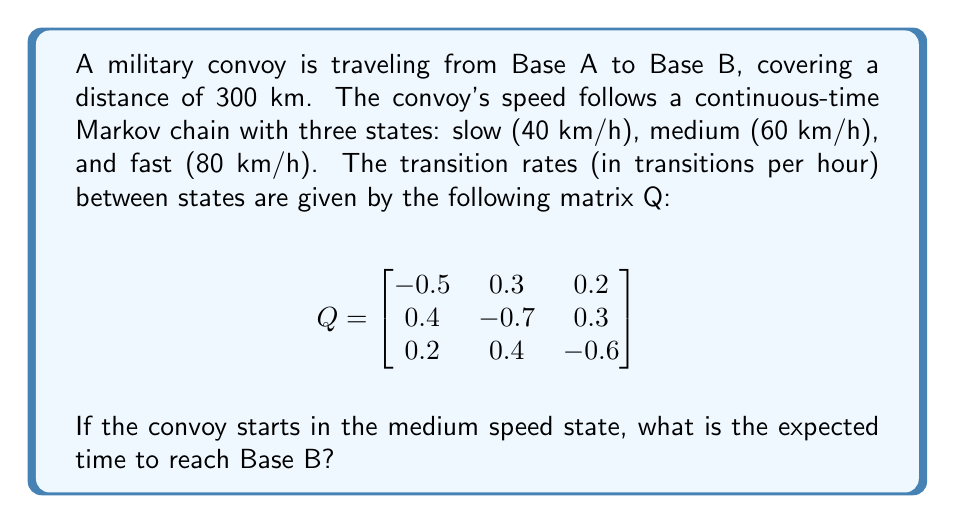Can you answer this question? To solve this problem, we need to use the theory of continuous-time Markov chains and expected hitting times. Let's approach this step-by-step:

1) First, we need to find the stationary distribution π of the Markov chain. This satisfies πQ = 0 and Σπᵢ = 1. Solving this system of equations:

   $$\begin{align}
   -0.5π₁ + 0.4π₂ + 0.2π₃ &= 0 \\
   0.3π₁ - 0.7π₂ + 0.4π₃ &= 0 \\
   π₁ + π₂ + π₃ &= 1
   \end{align}$$

   We get: π ≈ (0.3846, 0.3077, 0.3077)

2) Now, we can calculate the expected speed of the convoy:

   $$E[V] = 40 * 0.3846 + 60 * 0.3077 + 80 * 0.3077 ≈ 58.46 \text{ km/h}$$

3) The expected time to cover 300 km at this average speed would be:

   $$E[T] = \frac{300}{58.46} ≈ 5.13 \text{ hours}$$

However, this is not the correct answer because the convoy starts in the medium speed state, not in the stationary distribution.

4) To account for the initial state, we need to use the fundamental matrix approach. Let T be the expected time to reach Base B. Then:

   $$T = e + QT$$

   where e is a column vector of ones and Q is our rate matrix.

5) Solving this equation:

   $$(I - Q)T = e$$
   $$T = (I - Q)^{-1}e$$

6) Calculating $(I - Q)^{-1}$:

   $$(I - Q)^{-1} ≈ \begin{bmatrix}
   2.6667 & 1.3333 & 1.1111 \\
   1.7778 & 2.4444 & 1.3333 \\
   1.3333 & 1.5556 & 2.2222
   \end{bmatrix}$$

7) Multiplying by e:

   $$T ≈ \begin{bmatrix}
   5.1111 \\
   5.5556 \\
   5.1111
   \end{bmatrix}$$

8) The convoy starts in the medium speed state (state 2), so we take the second element of this vector.

Therefore, the expected time to reach Base B, starting from the medium speed state, is approximately 5.5556 hours.
Answer: 5.5556 hours 